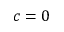Convert formula to latex. <formula><loc_0><loc_0><loc_500><loc_500>c = 0</formula> 